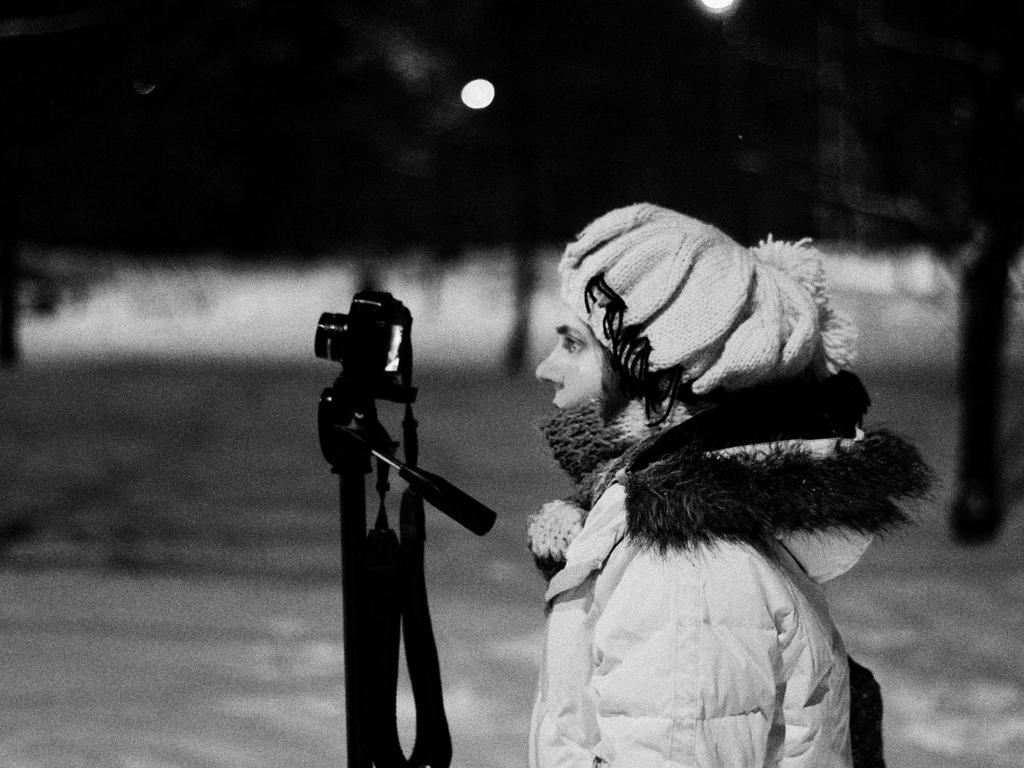Who or what is the main subject of the image? There is a person in the image. What object is also visible in the image? There is a camera in the image. Can you describe the other items in the image? There are some objects in the image. How would you characterize the background of the image? The background of the image is blurry. What is the organization's opinion on the button in the image? There is no organization or button present in the image, so it is not possible to answer that question. 